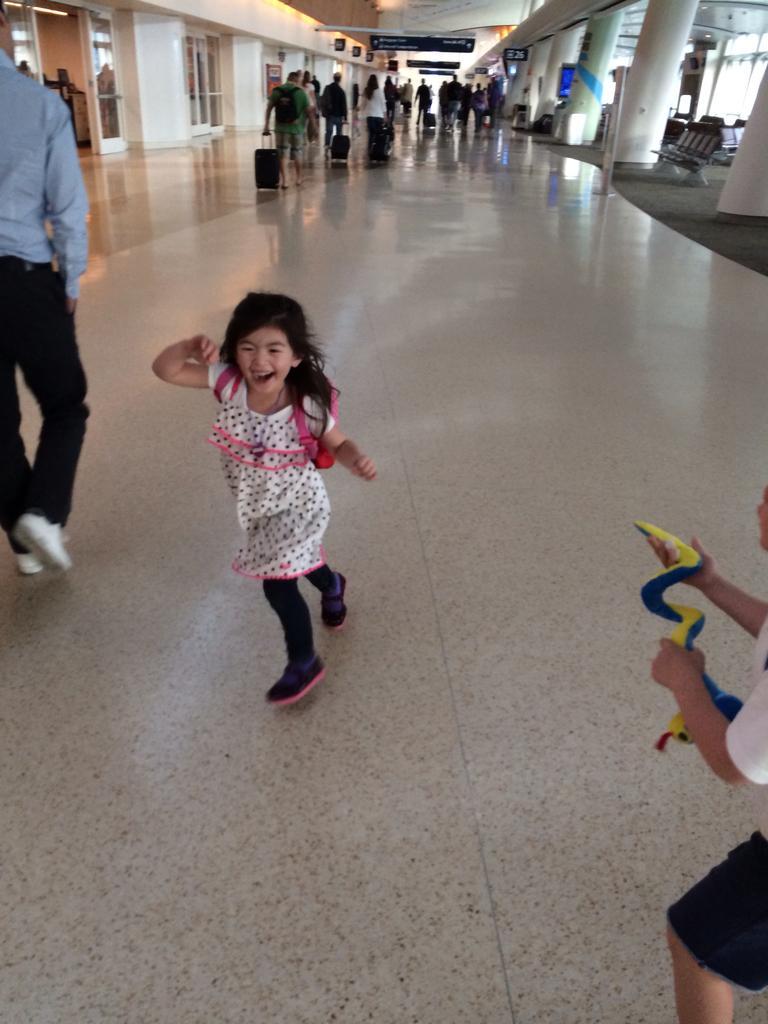Can you describe this image briefly? In this image we can see a girl is running. She is wearing pink color dress. Right side of the image pillars are there. Background of the image so many people are walking by holding suitcases. Right bottom of the image one boy is there who is holding yellow color thing in his hand. 